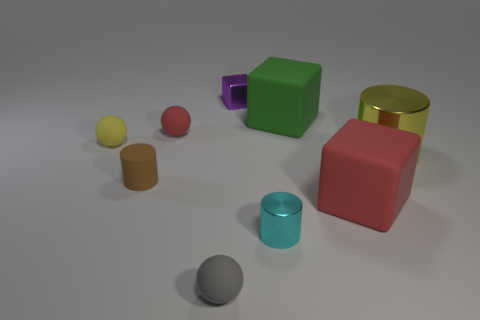Subtract all balls. How many objects are left? 6 Subtract 0 cyan balls. How many objects are left? 9 Subtract all brown metallic cylinders. Subtract all small yellow spheres. How many objects are left? 8 Add 4 large yellow metal things. How many large yellow metal things are left? 5 Add 8 green matte cubes. How many green matte cubes exist? 9 